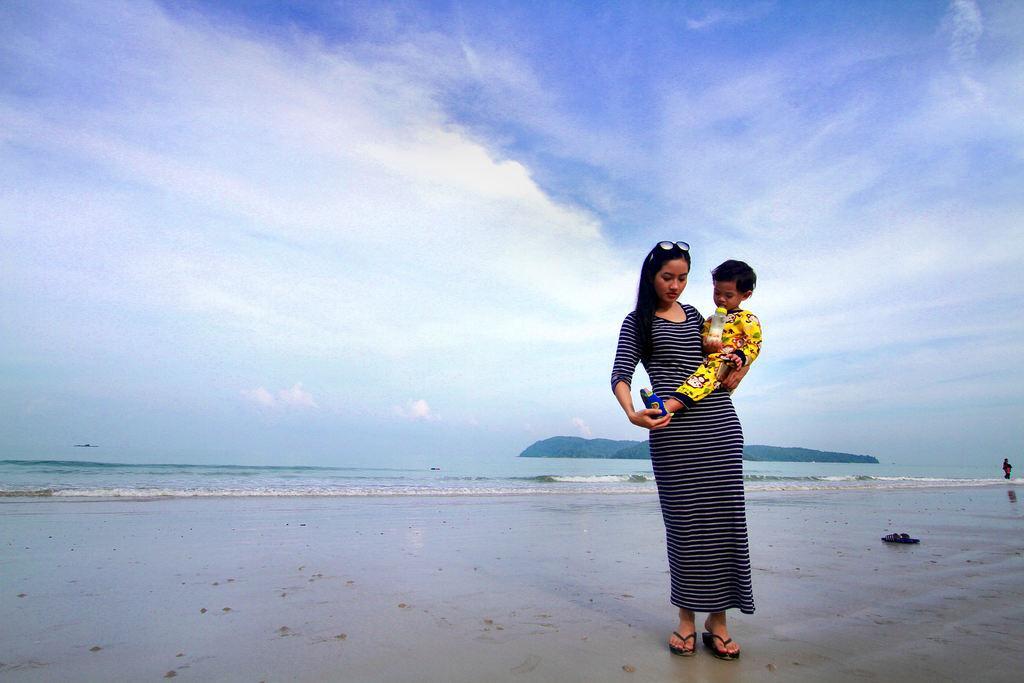Could you give a brief overview of what you see in this image? In this image we can see a woman is holding a baby. Here we can see a bottle, footwear, sand, water, and a person. In the background we can see a mountain and sky with clouds. 